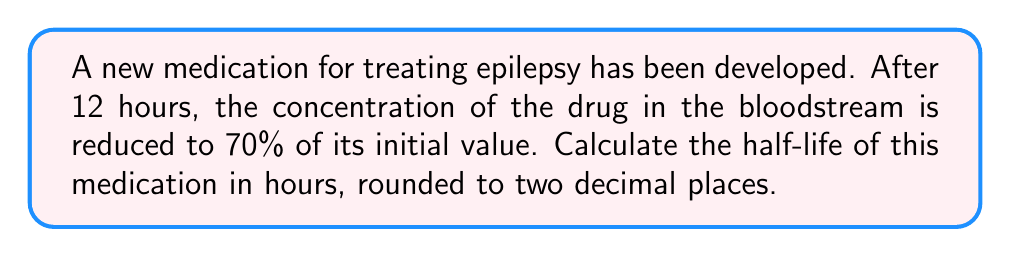Teach me how to tackle this problem. Let's approach this step-by-step using logarithms:

1) The half-life is the time it takes for the concentration to reduce to half its initial value. We need to find this time using the given information.

2) Let's define our variables:
   $t$ = time (12 hours in this case)
   $A$ = final amount (70% or 0.7 of initial)
   $A_0$ = initial amount (100% or 1)
   $k$ = decay constant
   $t_{1/2}$ = half-life

3) The exponential decay formula is:
   $A = A_0 e^{-kt}$

4) Substituting our known values:
   $0.7 = 1 \cdot e^{-k(12)}$

5) Taking natural log of both sides:
   $\ln(0.7) = -12k$

6) Solving for $k$:
   $k = -\frac{\ln(0.7)}{12} \approx 0.0297$

7) Now, we can use the relationship between half-life and decay constant:
   $t_{1/2} = \frac{\ln(2)}{k}$

8) Substituting our $k$ value:
   $t_{1/2} = \frac{\ln(2)}{0.0297} \approx 23.34$ hours

9) Rounding to two decimal places: 23.34 hours
Answer: 23.34 hours 